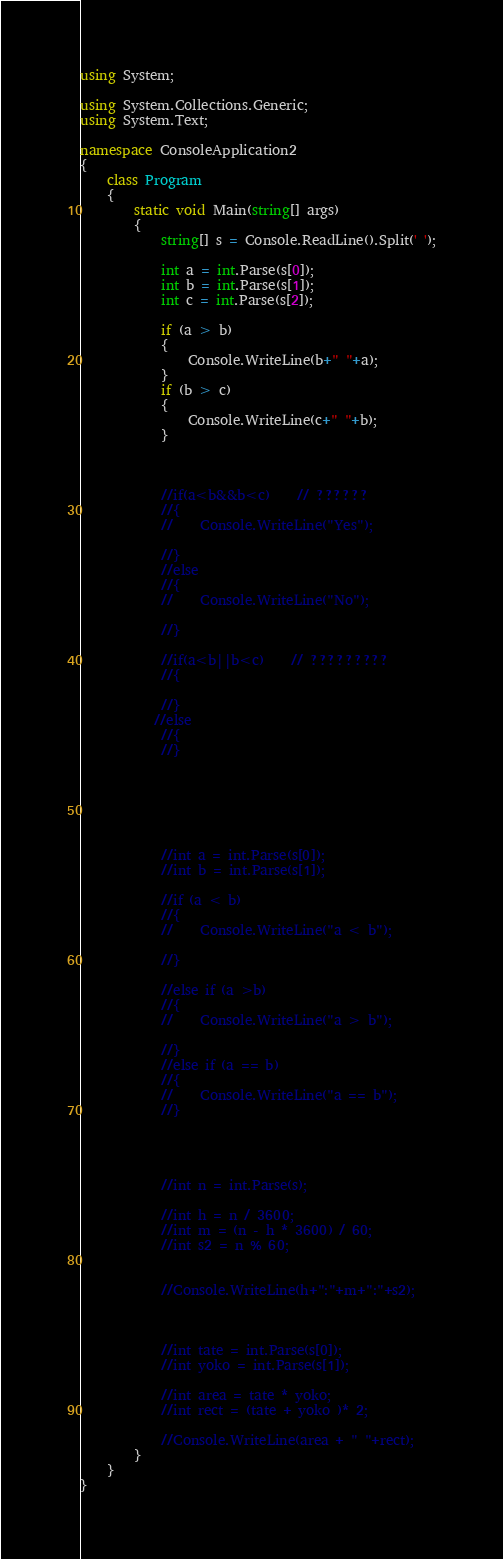Convert code to text. <code><loc_0><loc_0><loc_500><loc_500><_C#_>using System;

using System.Collections.Generic;
using System.Text;

namespace ConsoleApplication2
{
    class Program
    {
        static void Main(string[] args)
        {
            string[] s = Console.ReadLine().Split(' ');

            int a = int.Parse(s[0]);
            int b = int.Parse(s[1]);
            int c = int.Parse(s[2]);

            if (a > b)
            {
                Console.WriteLine(b+" "+a);
            }
            if (b > c)
            {
                Console.WriteLine(c+" "+b);
            }
          


            //if(a<b&&b<c)    // ??????
            //{
            //    Console.WriteLine("Yes");

            //}
            //else
            //{
            //    Console.WriteLine("No");

            //}

            //if(a<b||b<c)    // ?????????
            //{

            //}
           //else
            //{ 
            //}
       


            


            //int a = int.Parse(s[0]);
            //int b = int.Parse(s[1]);

            //if (a < b)
            //{
            //    Console.WriteLine("a < b");

            //}

            //else if (a >b)
            //{
            //    Console.WriteLine("a > b");

            //}
            //else if (a == b)
            //{
            //    Console.WriteLine("a == b");
            //}




            //int n = int.Parse(s);

            //int h = n / 3600;
            //int m = (n - h * 3600) / 60;
            //int s2 = n % 60;


            //Console.WriteLine(h+":"+m+":"+s2);



            //int tate = int.Parse(s[0]);
            //int yoko = int.Parse(s[1]);

            //int area = tate * yoko;
            //int rect = (tate + yoko )* 2;

            //Console.WriteLine(area + " "+rect);
        }
    }
}</code> 